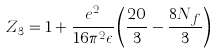Convert formula to latex. <formula><loc_0><loc_0><loc_500><loc_500>Z _ { 3 } = 1 + \frac { e ^ { 2 } } { 1 6 \pi ^ { 2 } \epsilon } \left ( \frac { 2 0 } { 3 } - \frac { 8 N _ { f } } { 3 } \right )</formula> 